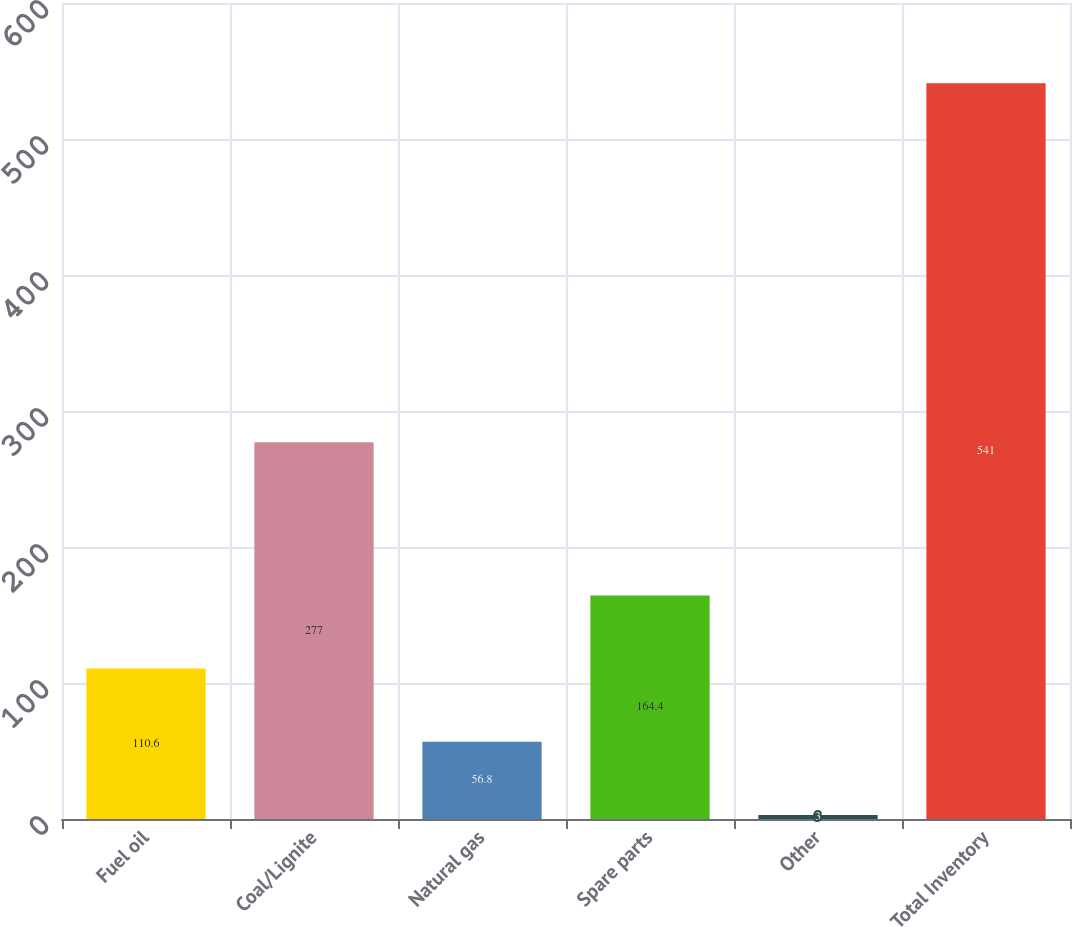Convert chart to OTSL. <chart><loc_0><loc_0><loc_500><loc_500><bar_chart><fcel>Fuel oil<fcel>Coal/Lignite<fcel>Natural gas<fcel>Spare parts<fcel>Other<fcel>Total Inventory<nl><fcel>110.6<fcel>277<fcel>56.8<fcel>164.4<fcel>3<fcel>541<nl></chart> 